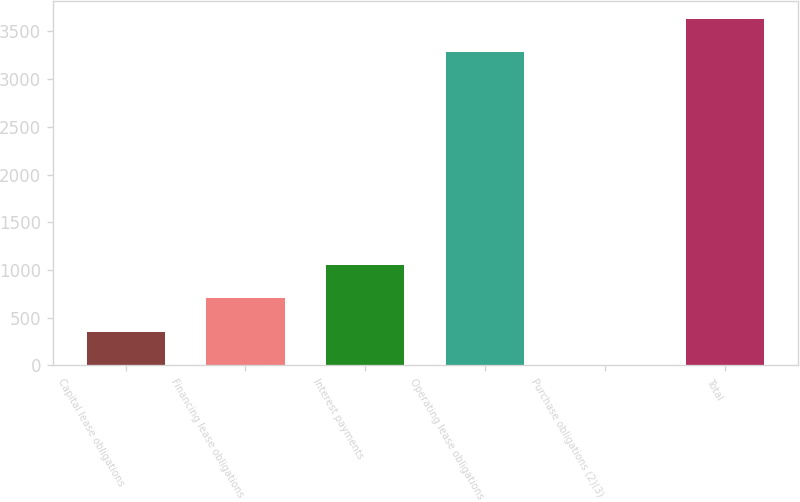Convert chart to OTSL. <chart><loc_0><loc_0><loc_500><loc_500><bar_chart><fcel>Capital lease obligations<fcel>Financing lease obligations<fcel>Interest payments<fcel>Operating lease obligations<fcel>Purchase obligations (2)(3)<fcel>Total<nl><fcel>352.8<fcel>702.6<fcel>1052.4<fcel>3282<fcel>3<fcel>3631.8<nl></chart> 